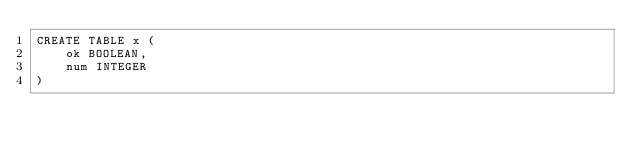Convert code to text. <code><loc_0><loc_0><loc_500><loc_500><_SQL_>CREATE TABLE x (
	ok BOOLEAN,
	num INTEGER
)
</code> 